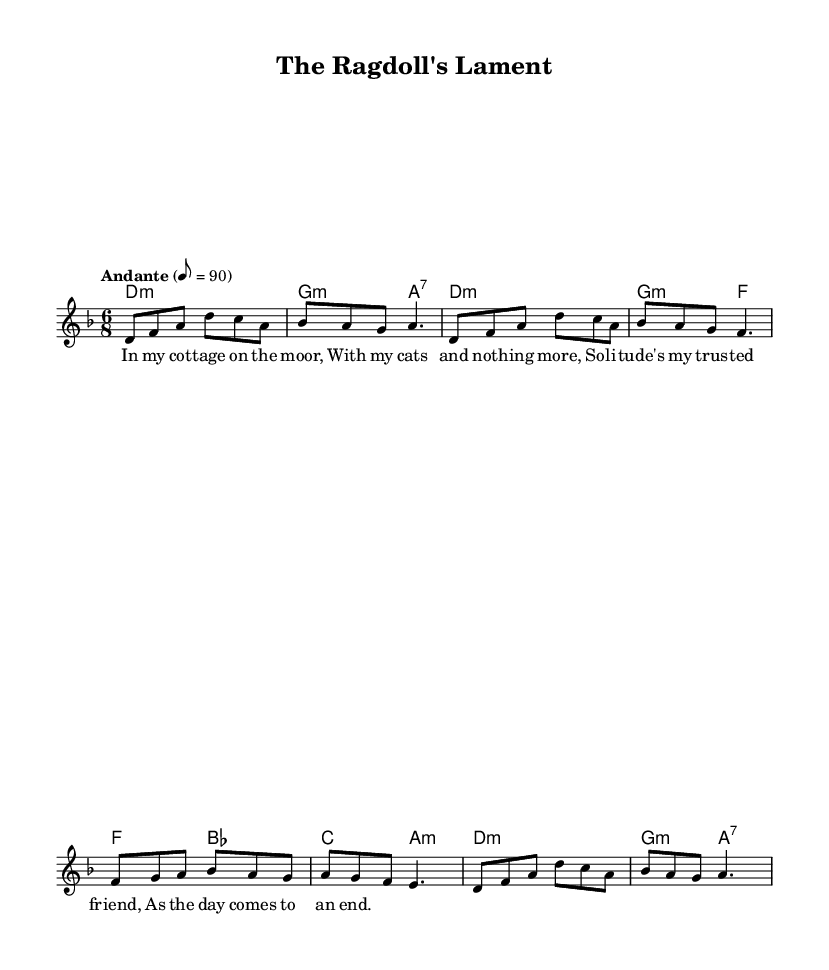What is the key signature of this music? The key signature is written at the beginning of the score and indicates that this piece is in D minor, which has one flat (B flat).
Answer: D minor What is the time signature of this music? The time signature is shown at the beginning of the score and indicates the piece is in 6/8 time, meaning there are six eighth notes in each measure.
Answer: 6/8 What is the tempo marking of this music? The tempo marking is written above the staff and indicates a moderate speed (Andante) of 90 beats per minute, referring to how fast the piece should be played.
Answer: Andante 8 = 90 What is the mood conveyed by the lyrics? The lyrics suggest a sense of solitude and companionship with cats, indicating a reflective and possibly melancholic mood that resonates with themes of loneliness and comfort.
Answer: Reflective How many measures are present in the melody? By counting the individual measures in the melody section, there are a total of eight measures as indicated by the bar lines that separate them.
Answer: 8 Which chord appears most frequently in the harmony section? By examining the harmony section, the D minor chord is repeated several times, indicating a structural significance within the piece, as it establishes the tonality.
Answer: D minor 